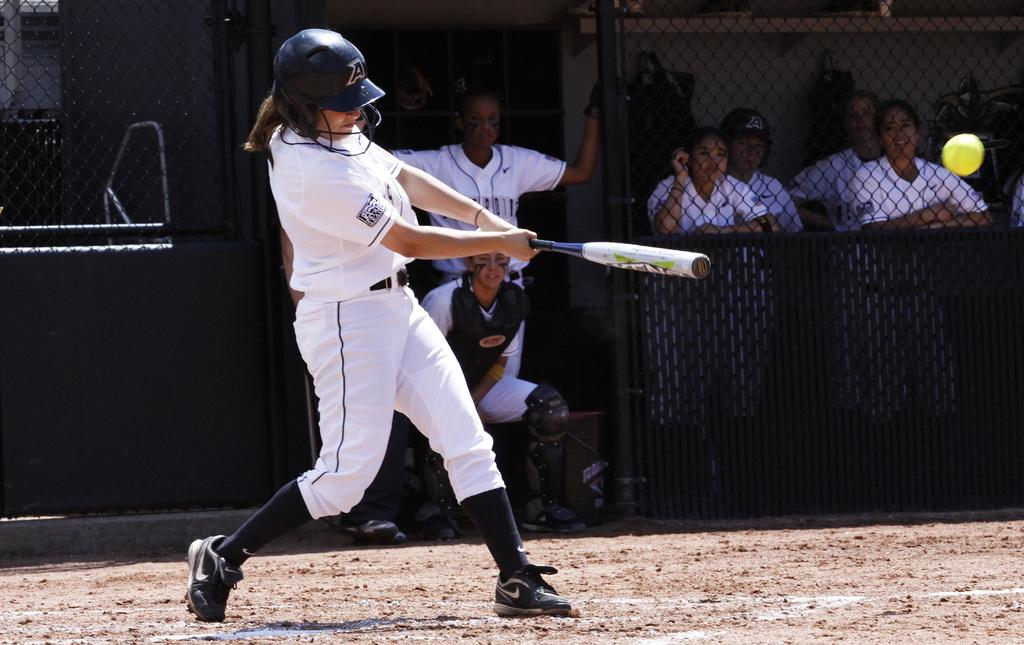<image>
Offer a succinct explanation of the picture presented. The player swinging the bat has a letter A on their helmet. 